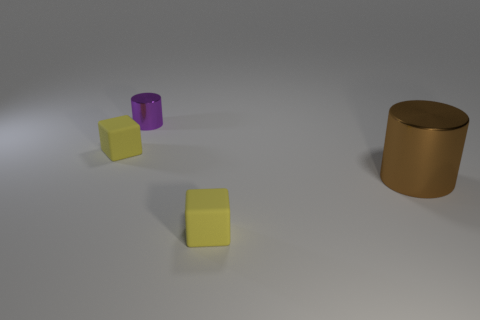Add 3 brown matte cubes. How many objects exist? 7 Add 2 yellow matte cubes. How many yellow matte cubes exist? 4 Subtract 0 red balls. How many objects are left? 4 Subtract all small metallic cylinders. Subtract all blocks. How many objects are left? 1 Add 2 rubber things. How many rubber things are left? 4 